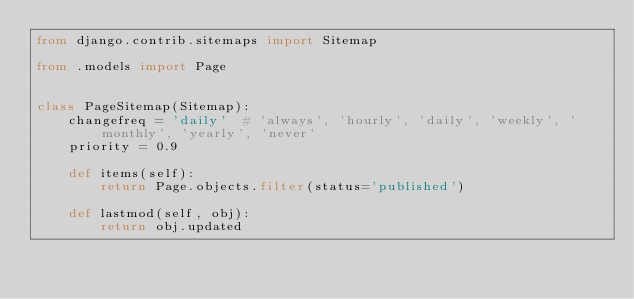Convert code to text. <code><loc_0><loc_0><loc_500><loc_500><_Python_>from django.contrib.sitemaps import Sitemap

from .models import Page


class PageSitemap(Sitemap):
    changefreq = 'daily'  # 'always', 'hourly', 'daily', 'weekly', 'monthly', 'yearly', 'never'
    priority = 0.9

    def items(self):
        return Page.objects.filter(status='published')

    def lastmod(self, obj):
        return obj.updated
</code> 